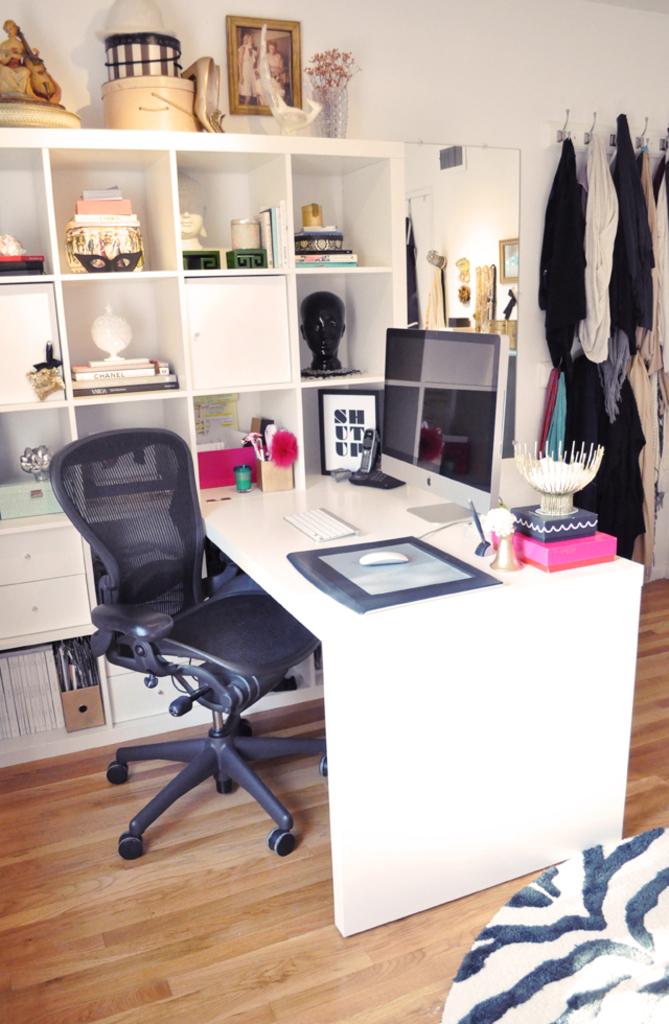What does it say in the framed picture?
Provide a short and direct response. Shut up. 